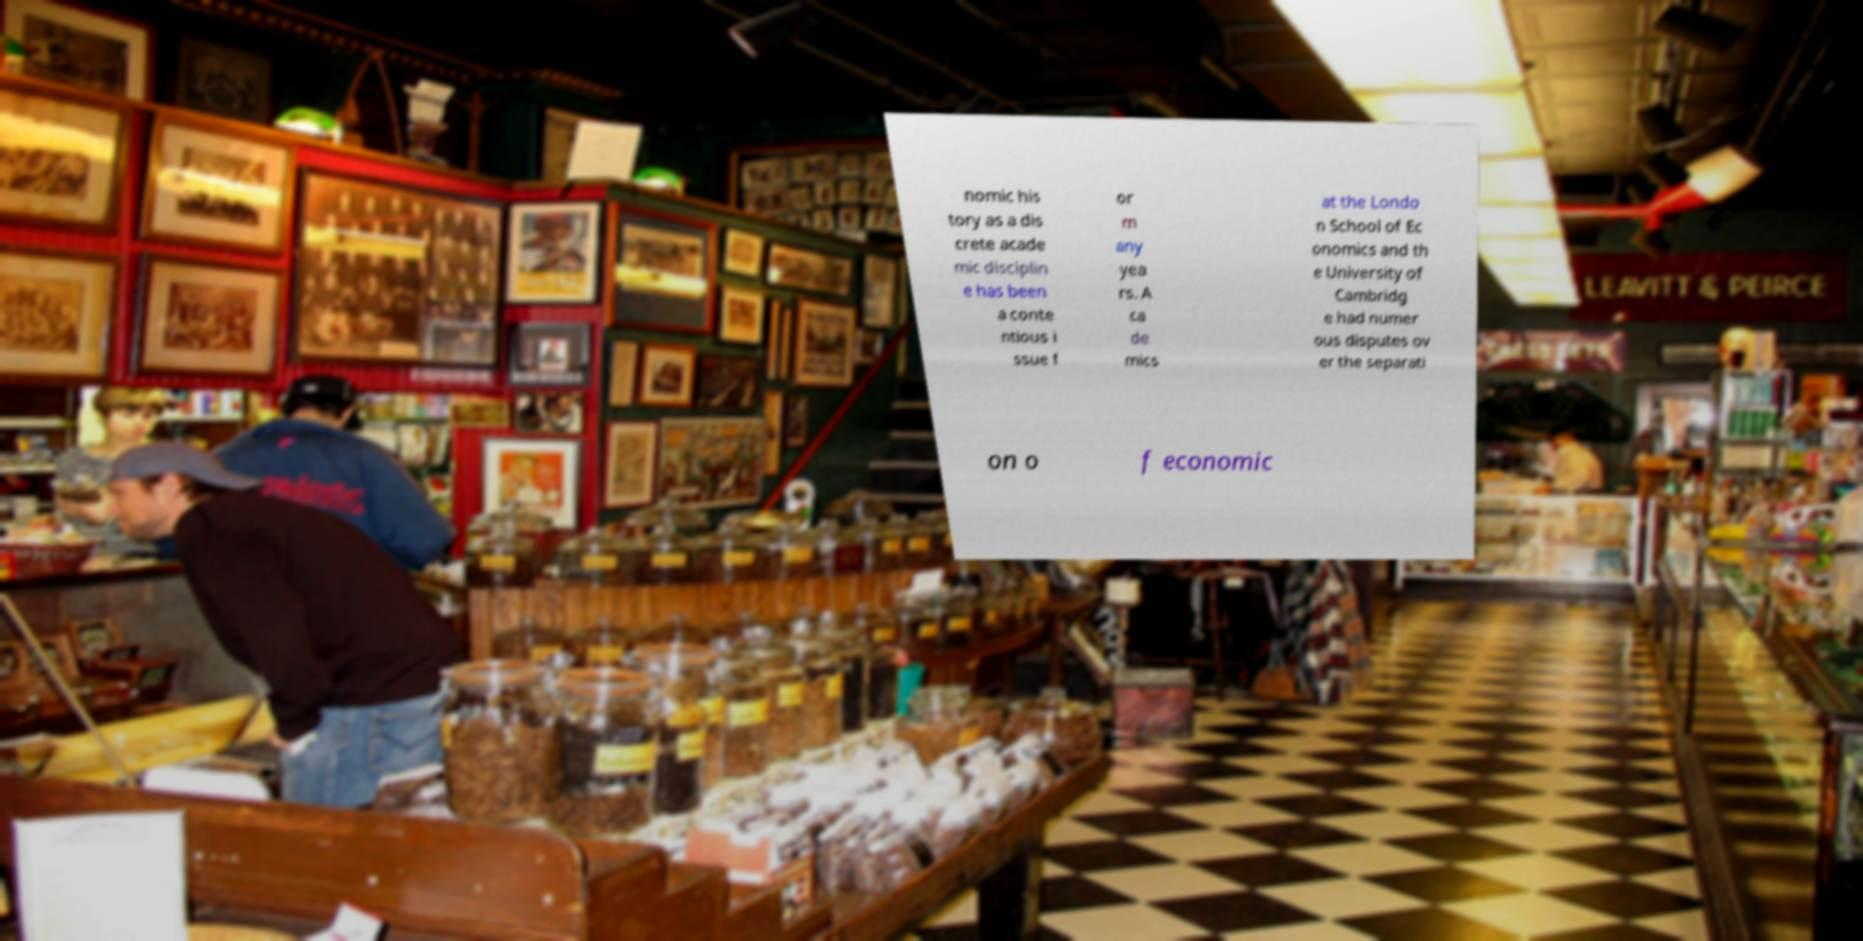I need the written content from this picture converted into text. Can you do that? nomic his tory as a dis crete acade mic disciplin e has been a conte ntious i ssue f or m any yea rs. A ca de mics at the Londo n School of Ec onomics and th e University of Cambridg e had numer ous disputes ov er the separati on o f economic 